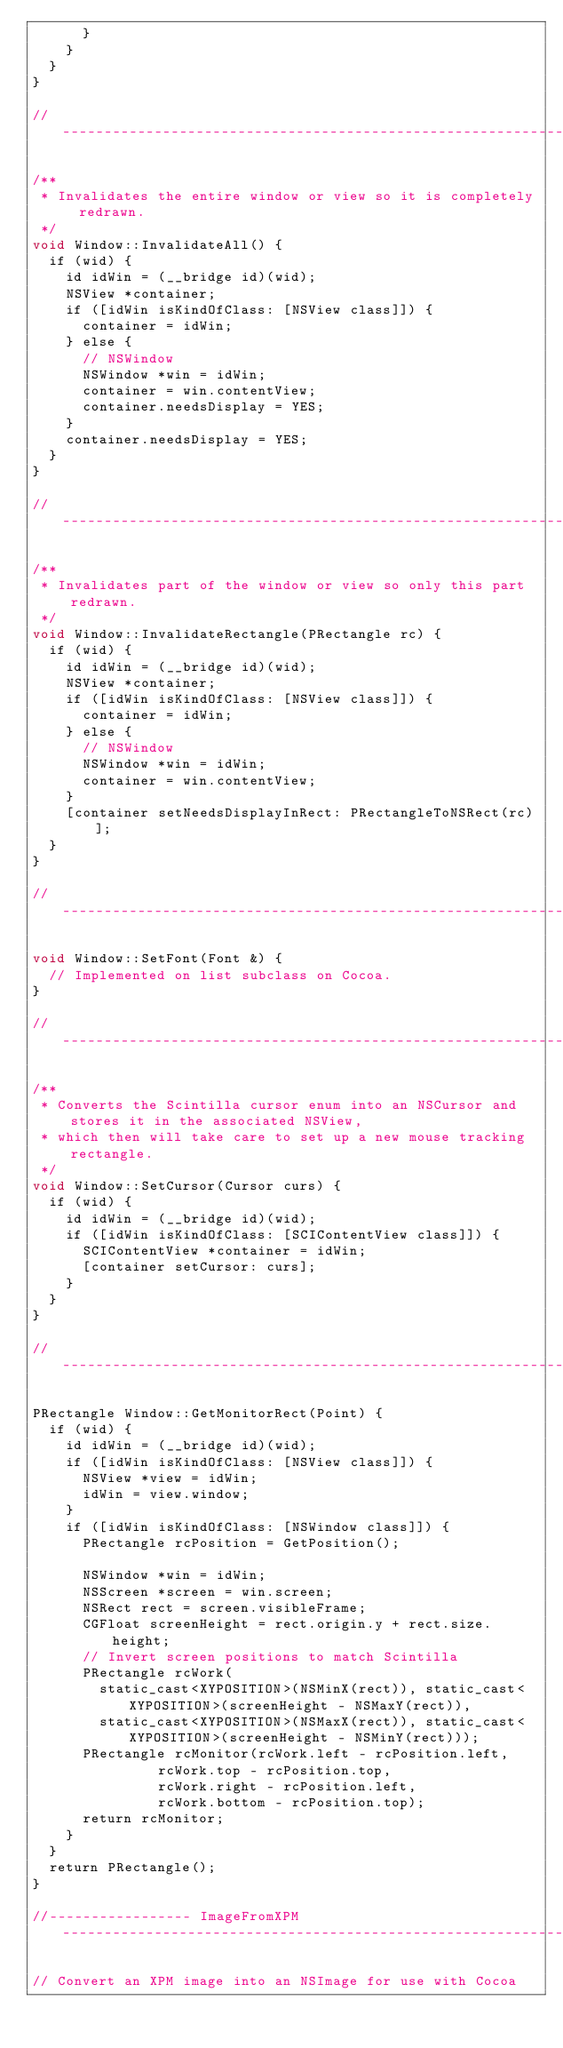Convert code to text. <code><loc_0><loc_0><loc_500><loc_500><_ObjectiveC_>			}
		}
	}
}

//--------------------------------------------------------------------------------------------------

/**
 * Invalidates the entire window or view so it is completely redrawn.
 */
void Window::InvalidateAll() {
	if (wid) {
		id idWin = (__bridge id)(wid);
		NSView *container;
		if ([idWin isKindOfClass: [NSView class]]) {
			container = idWin;
		} else {
			// NSWindow
			NSWindow *win = idWin;
			container = win.contentView;
			container.needsDisplay = YES;
		}
		container.needsDisplay = YES;
	}
}

//--------------------------------------------------------------------------------------------------

/**
 * Invalidates part of the window or view so only this part redrawn.
 */
void Window::InvalidateRectangle(PRectangle rc) {
	if (wid) {
		id idWin = (__bridge id)(wid);
		NSView *container;
		if ([idWin isKindOfClass: [NSView class]]) {
			container = idWin;
		} else {
			// NSWindow
			NSWindow *win = idWin;
			container = win.contentView;
		}
		[container setNeedsDisplayInRect: PRectangleToNSRect(rc)];
	}
}

//--------------------------------------------------------------------------------------------------

void Window::SetFont(Font &) {
	// Implemented on list subclass on Cocoa.
}

//--------------------------------------------------------------------------------------------------

/**
 * Converts the Scintilla cursor enum into an NSCursor and stores it in the associated NSView,
 * which then will take care to set up a new mouse tracking rectangle.
 */
void Window::SetCursor(Cursor curs) {
	if (wid) {
		id idWin = (__bridge id)(wid);
		if ([idWin isKindOfClass: [SCIContentView class]]) {
			SCIContentView *container = idWin;
			[container setCursor: curs];
		}
	}
}

//--------------------------------------------------------------------------------------------------

PRectangle Window::GetMonitorRect(Point) {
	if (wid) {
		id idWin = (__bridge id)(wid);
		if ([idWin isKindOfClass: [NSView class]]) {
			NSView *view = idWin;
			idWin = view.window;
		}
		if ([idWin isKindOfClass: [NSWindow class]]) {
			PRectangle rcPosition = GetPosition();

			NSWindow *win = idWin;
			NSScreen *screen = win.screen;
			NSRect rect = screen.visibleFrame;
			CGFloat screenHeight = rect.origin.y + rect.size.height;
			// Invert screen positions to match Scintilla
			PRectangle rcWork(
				static_cast<XYPOSITION>(NSMinX(rect)), static_cast<XYPOSITION>(screenHeight - NSMaxY(rect)),
				static_cast<XYPOSITION>(NSMaxX(rect)), static_cast<XYPOSITION>(screenHeight - NSMinY(rect)));
			PRectangle rcMonitor(rcWork.left - rcPosition.left,
					     rcWork.top - rcPosition.top,
					     rcWork.right - rcPosition.left,
					     rcWork.bottom - rcPosition.top);
			return rcMonitor;
		}
	}
	return PRectangle();
}

//----------------- ImageFromXPM -------------------------------------------------------------------

// Convert an XPM image into an NSImage for use with Cocoa
</code> 